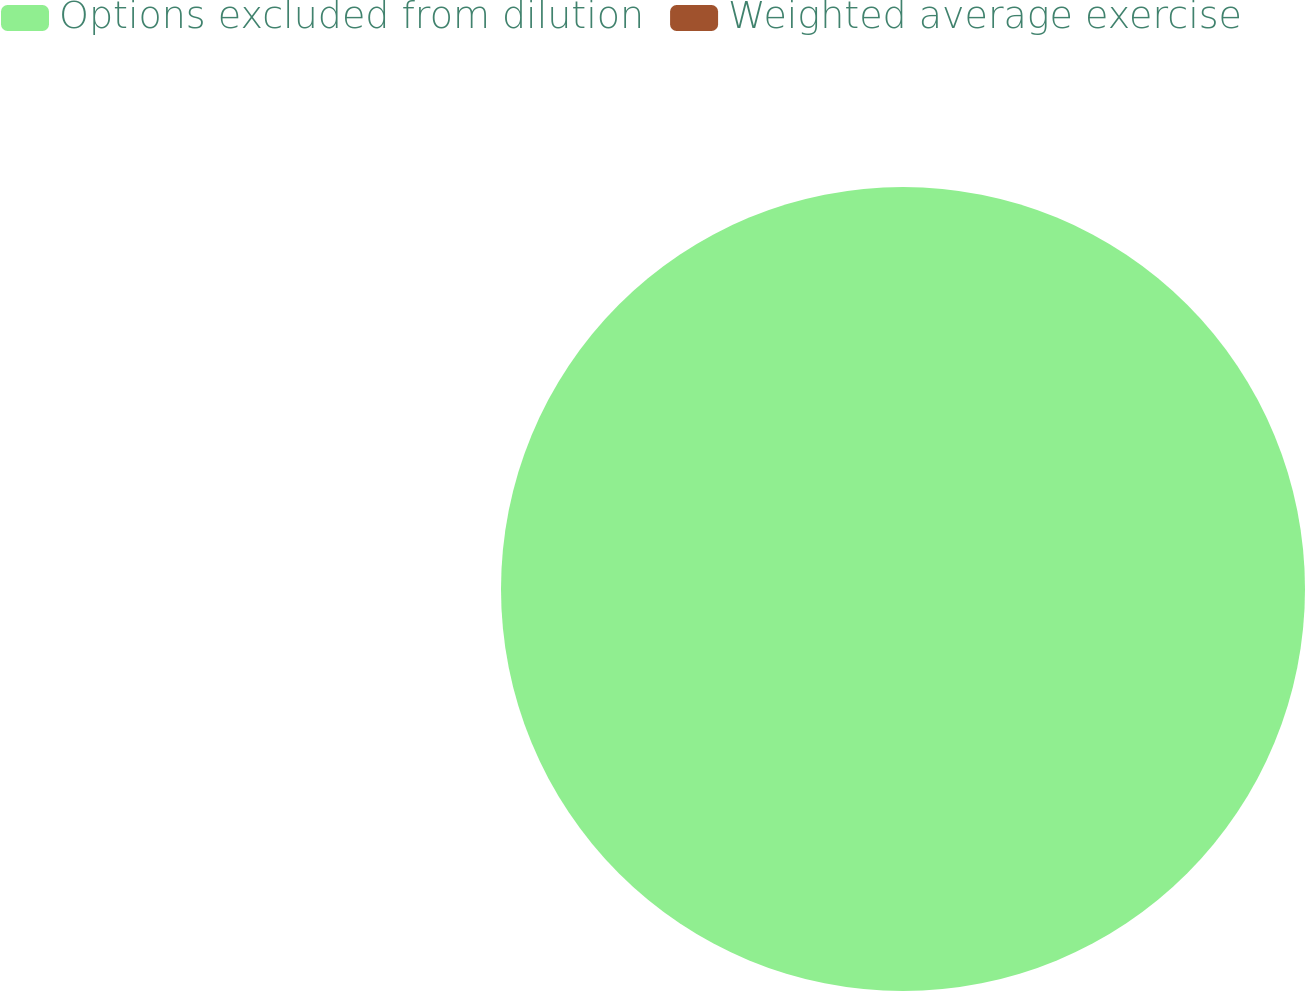<chart> <loc_0><loc_0><loc_500><loc_500><pie_chart><fcel>Options excluded from dilution<fcel>Weighted average exercise<nl><fcel>100.0%<fcel>0.0%<nl></chart> 